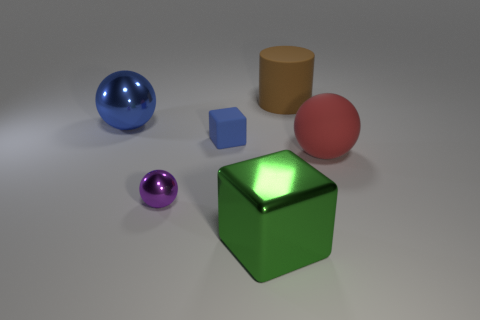Subtract all big balls. How many balls are left? 1 Add 2 purple shiny objects. How many objects exist? 8 Subtract 1 spheres. How many spheres are left? 2 Subtract all blocks. How many objects are left? 4 Subtract 0 yellow cylinders. How many objects are left? 6 Subtract all green matte cylinders. Subtract all small matte objects. How many objects are left? 5 Add 4 red balls. How many red balls are left? 5 Add 4 green metal objects. How many green metal objects exist? 5 